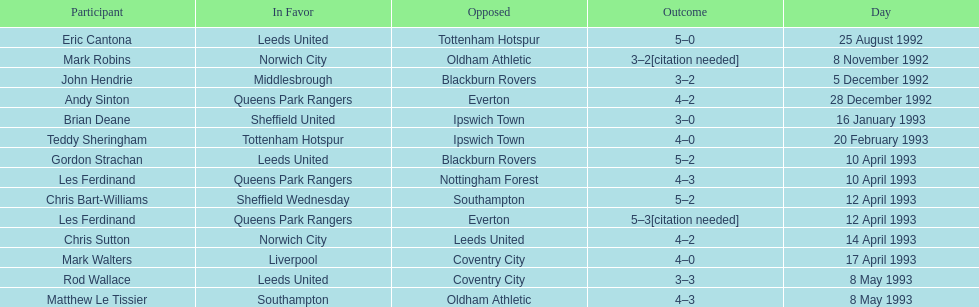Can you give me this table as a dict? {'header': ['Participant', 'In Favor', 'Opposed', 'Outcome', 'Day'], 'rows': [['Eric Cantona', 'Leeds United', 'Tottenham Hotspur', '5–0', '25 August 1992'], ['Mark Robins', 'Norwich City', 'Oldham Athletic', '3–2[citation needed]', '8 November 1992'], ['John Hendrie', 'Middlesbrough', 'Blackburn Rovers', '3–2', '5 December 1992'], ['Andy Sinton', 'Queens Park Rangers', 'Everton', '4–2', '28 December 1992'], ['Brian Deane', 'Sheffield United', 'Ipswich Town', '3–0', '16 January 1993'], ['Teddy Sheringham', 'Tottenham Hotspur', 'Ipswich Town', '4–0', '20 February 1993'], ['Gordon Strachan', 'Leeds United', 'Blackburn Rovers', '5–2', '10 April 1993'], ['Les Ferdinand', 'Queens Park Rangers', 'Nottingham Forest', '4–3', '10 April 1993'], ['Chris Bart-Williams', 'Sheffield Wednesday', 'Southampton', '5–2', '12 April 1993'], ['Les Ferdinand', 'Queens Park Rangers', 'Everton', '5–3[citation needed]', '12 April 1993'], ['Chris Sutton', 'Norwich City', 'Leeds United', '4–2', '14 April 1993'], ['Mark Walters', 'Liverpool', 'Coventry City', '4–0', '17 April 1993'], ['Rod Wallace', 'Leeds United', 'Coventry City', '3–3', '8 May 1993'], ['Matthew Le Tissier', 'Southampton', 'Oldham Athletic', '4–3', '8 May 1993']]} In the 1992-1993 premier league, what was the total number of hat tricks scored by all players? 14. 